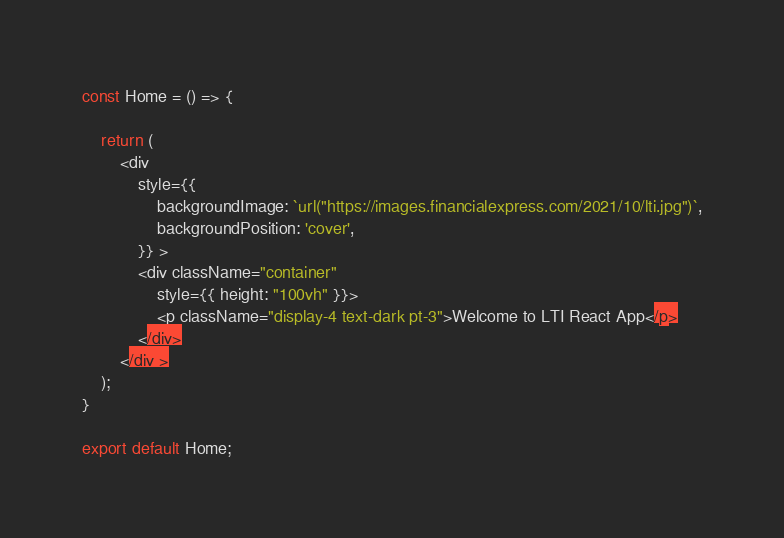<code> <loc_0><loc_0><loc_500><loc_500><_JavaScript_>const Home = () => {

    return (
        <div
            style={{
                backgroundImage: `url("https://images.financialexpress.com/2021/10/lti.jpg")`,
                backgroundPosition: 'cover',
            }} >
            <div className="container"
                style={{ height: "100vh" }}>
                <p className="display-4 text-dark pt-3">Welcome to LTI React App</p>
            </div>
        </div >
    );
}

export default Home;

</code> 